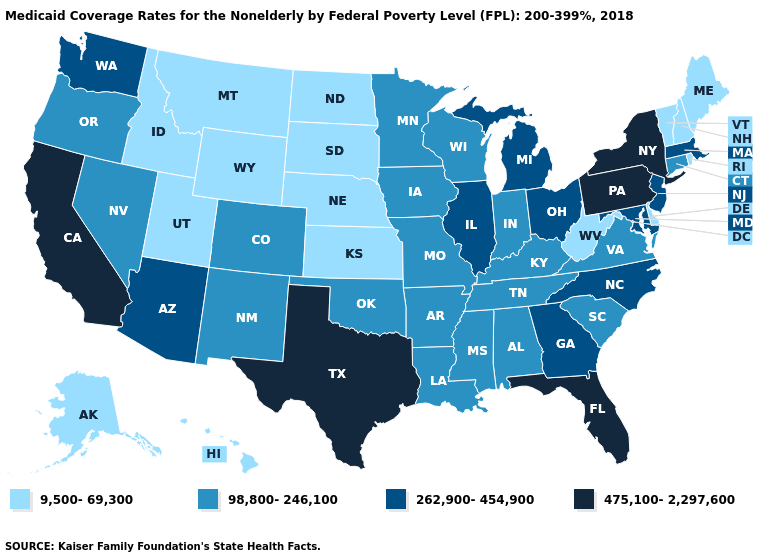Name the states that have a value in the range 475,100-2,297,600?
Quick response, please. California, Florida, New York, Pennsylvania, Texas. What is the highest value in the South ?
Short answer required. 475,100-2,297,600. Name the states that have a value in the range 475,100-2,297,600?
Be succinct. California, Florida, New York, Pennsylvania, Texas. Among the states that border Kansas , which have the highest value?
Write a very short answer. Colorado, Missouri, Oklahoma. Does the first symbol in the legend represent the smallest category?
Short answer required. Yes. What is the lowest value in the West?
Short answer required. 9,500-69,300. What is the value of California?
Short answer required. 475,100-2,297,600. Name the states that have a value in the range 475,100-2,297,600?
Keep it brief. California, Florida, New York, Pennsylvania, Texas. Name the states that have a value in the range 262,900-454,900?
Give a very brief answer. Arizona, Georgia, Illinois, Maryland, Massachusetts, Michigan, New Jersey, North Carolina, Ohio, Washington. Name the states that have a value in the range 98,800-246,100?
Short answer required. Alabama, Arkansas, Colorado, Connecticut, Indiana, Iowa, Kentucky, Louisiana, Minnesota, Mississippi, Missouri, Nevada, New Mexico, Oklahoma, Oregon, South Carolina, Tennessee, Virginia, Wisconsin. Which states have the lowest value in the South?
Give a very brief answer. Delaware, West Virginia. Among the states that border West Virginia , which have the highest value?
Short answer required. Pennsylvania. Among the states that border Rhode Island , does Connecticut have the lowest value?
Concise answer only. Yes. Among the states that border Massachusetts , which have the highest value?
Give a very brief answer. New York. What is the value of Utah?
Be succinct. 9,500-69,300. 